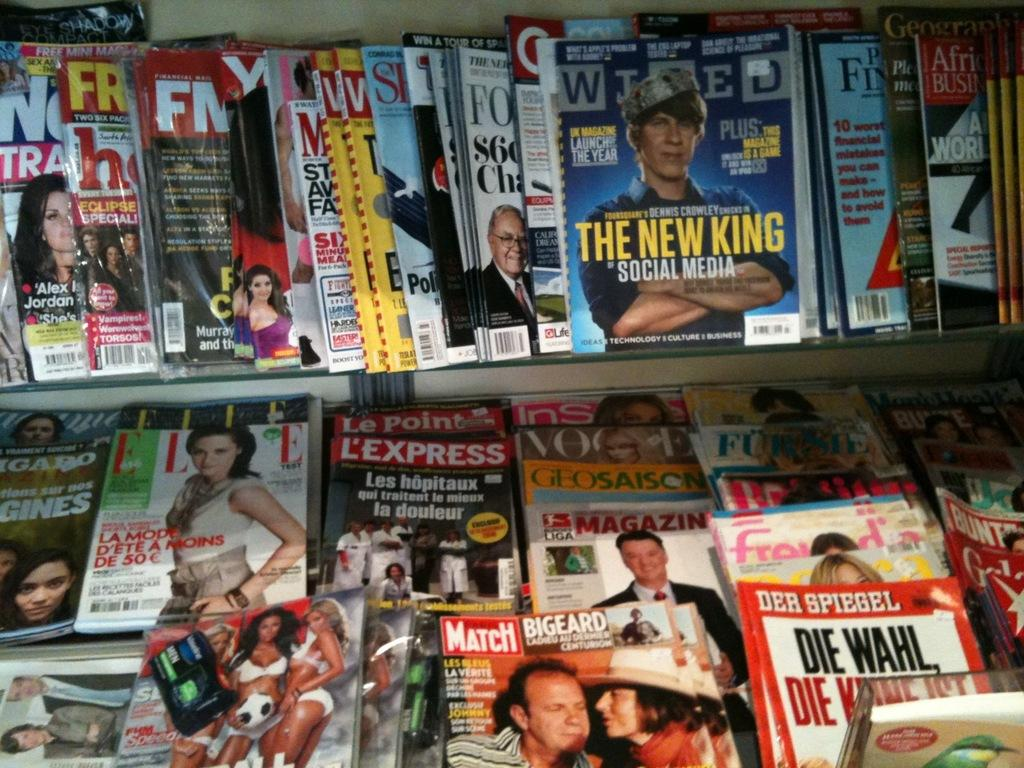Provide a one-sentence caption for the provided image. a bunch of magazines, one of which is called Match. 